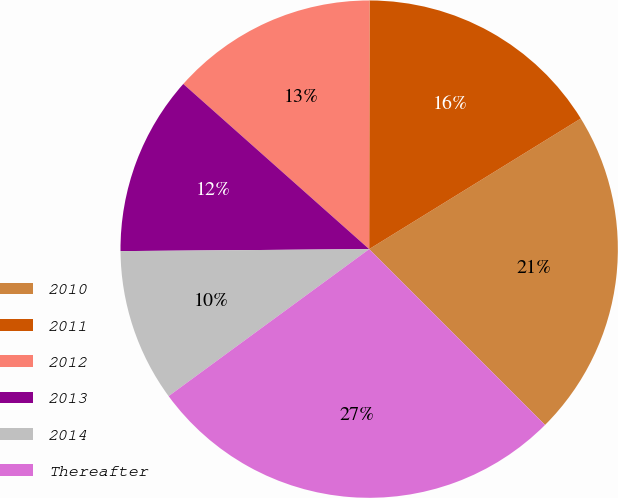Convert chart. <chart><loc_0><loc_0><loc_500><loc_500><pie_chart><fcel>2010<fcel>2011<fcel>2012<fcel>2013<fcel>2014<fcel>Thereafter<nl><fcel>21.3%<fcel>16.18%<fcel>13.46%<fcel>11.69%<fcel>9.94%<fcel>27.44%<nl></chart> 